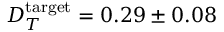Convert formula to latex. <formula><loc_0><loc_0><loc_500><loc_500>D _ { T } ^ { t \arg e t } = 0 . 2 9 \pm 0 . 0 8</formula> 